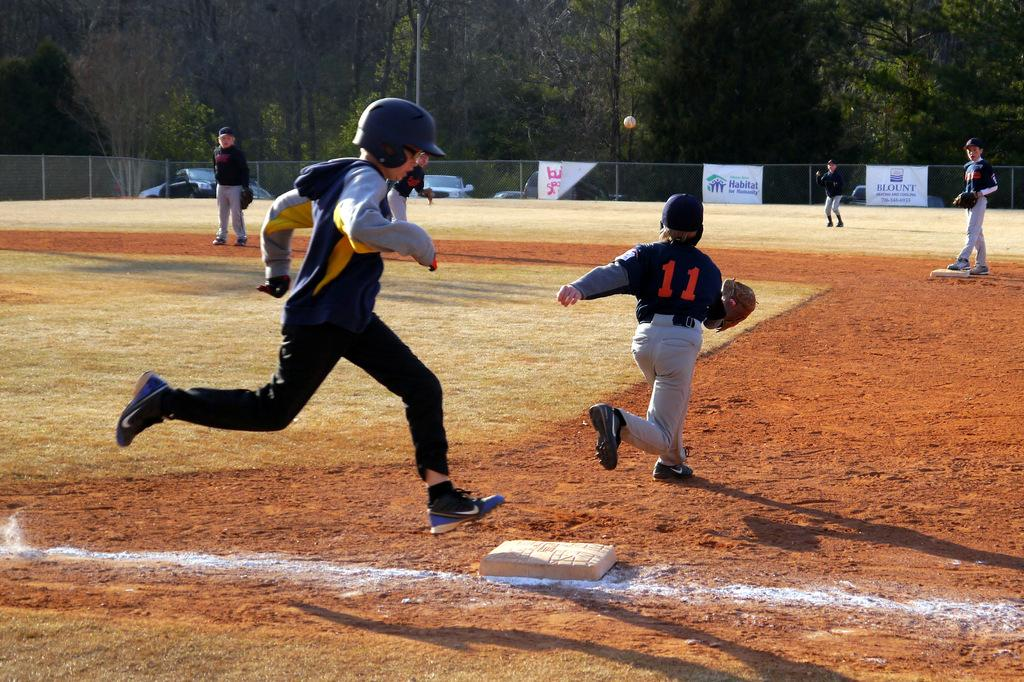What are the people in the image doing? There are people standing and running in the image. What can be seen in the background of the image? Net fencing, trees, vehicles, a pole, and banners are visible in the background. How many types of activities are the people engaged in? The people are engaged in two types of activities: standing and running. What type of powder is being used by the secretary in the image? There is no secretary or powder present in the image. Is the image taking place during the night or day? The image does not provide any information about the time of day, so it cannot be determined whether it is night or day. 